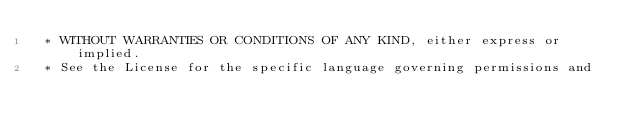<code> <loc_0><loc_0><loc_500><loc_500><_Cuda_> * WITHOUT WARRANTIES OR CONDITIONS OF ANY KIND, either express or implied.
 * See the License for the specific language governing permissions and</code> 